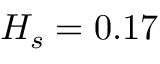Convert formula to latex. <formula><loc_0><loc_0><loc_500><loc_500>H _ { s } = 0 . 1 7</formula> 